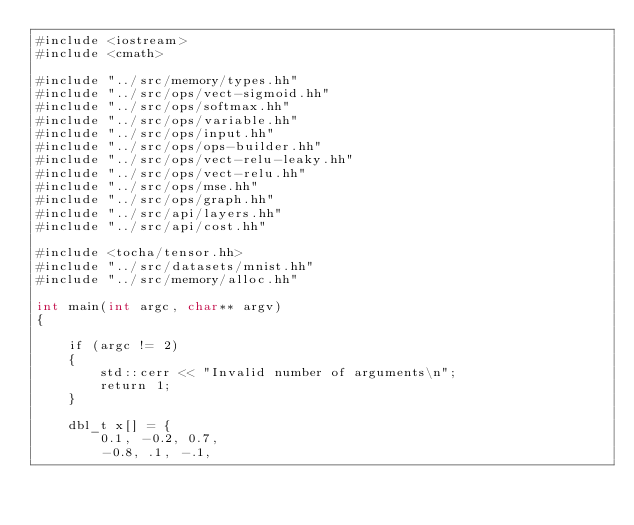Convert code to text. <code><loc_0><loc_0><loc_500><loc_500><_Cuda_>#include <iostream>
#include <cmath>

#include "../src/memory/types.hh"
#include "../src/ops/vect-sigmoid.hh"
#include "../src/ops/softmax.hh"
#include "../src/ops/variable.hh"
#include "../src/ops/input.hh"
#include "../src/ops/ops-builder.hh"
#include "../src/ops/vect-relu-leaky.hh"
#include "../src/ops/vect-relu.hh"
#include "../src/ops/mse.hh"
#include "../src/ops/graph.hh"
#include "../src/api/layers.hh"
#include "../src/api/cost.hh"

#include <tocha/tensor.hh>
#include "../src/datasets/mnist.hh"
#include "../src/memory/alloc.hh"

int main(int argc, char** argv)
{

    if (argc != 2)
    {
        std::cerr << "Invalid number of arguments\n";
        return 1;
    }    

    dbl_t x[] = {
        0.1, -0.2, 0.7,
        -0.8, .1, -.1,</code> 